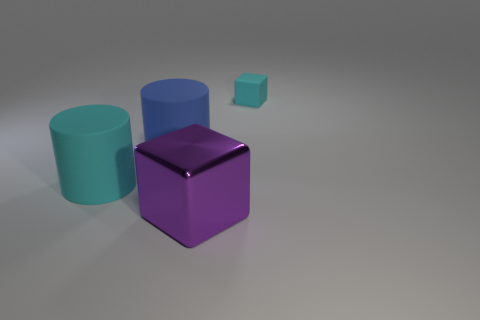Add 1 cyan matte things. How many objects exist? 5 Subtract all large purple cubes. Subtract all large cyan matte objects. How many objects are left? 2 Add 4 large purple metal objects. How many large purple metal objects are left? 5 Add 2 green matte cylinders. How many green matte cylinders exist? 2 Subtract 0 yellow cylinders. How many objects are left? 4 